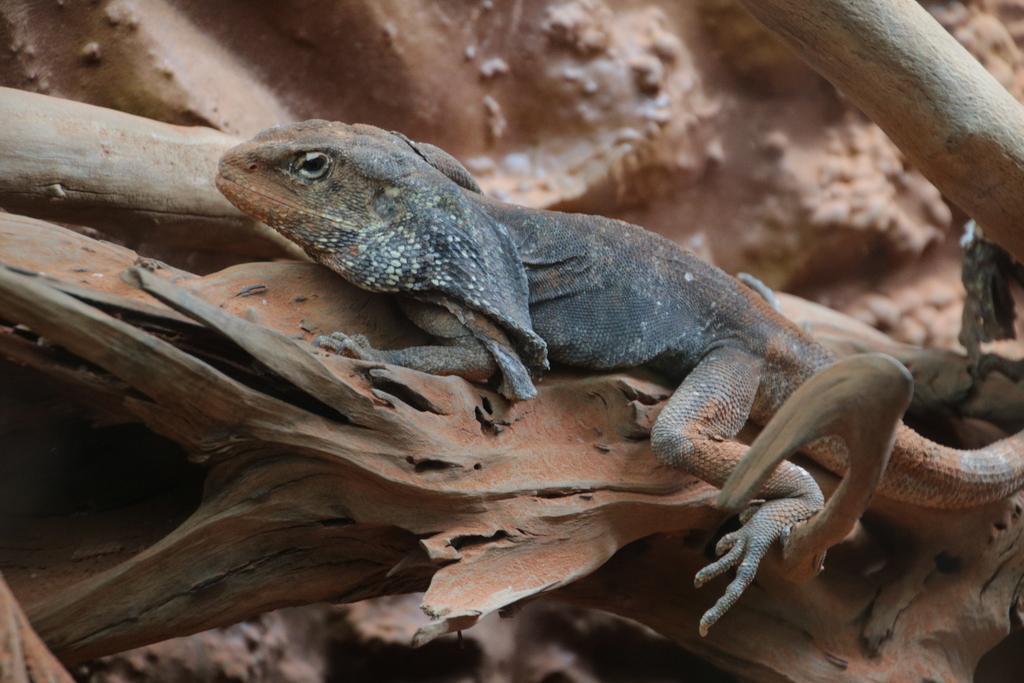Can you describe this image briefly? In the center of the image we can see reptile on the tree. 